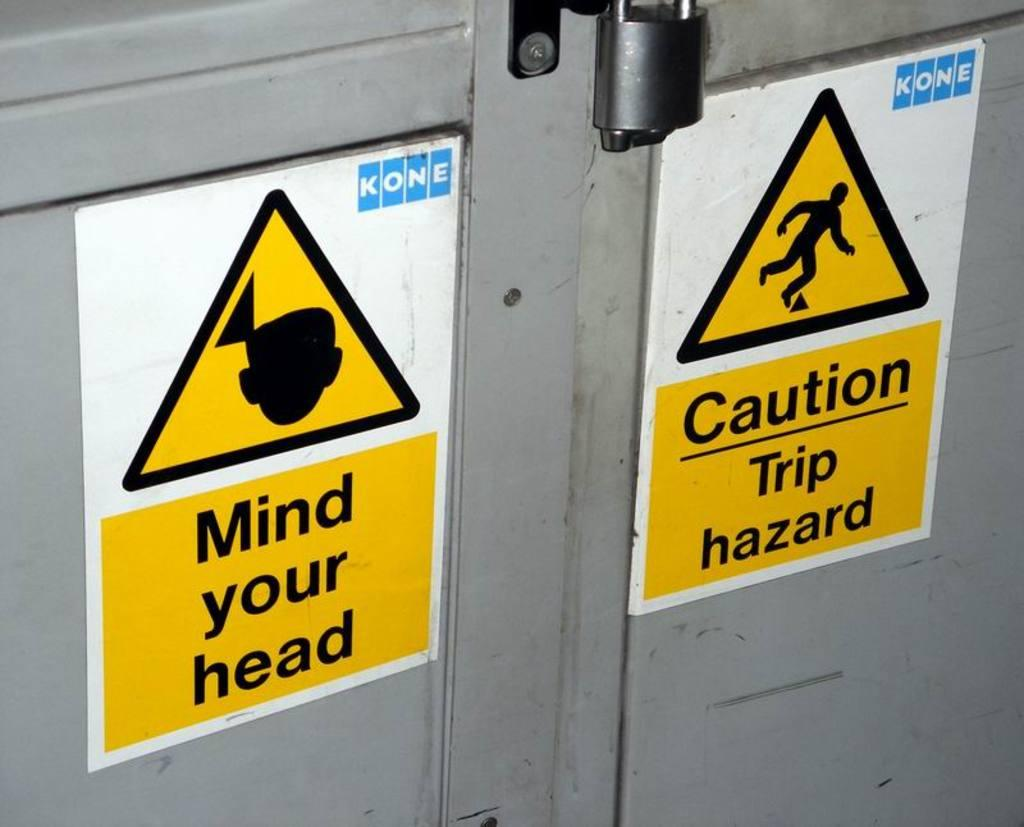<image>
Summarize the visual content of the image. Two signs on a grey metal cabinet, one of which reads 'Mind Your Head.' 